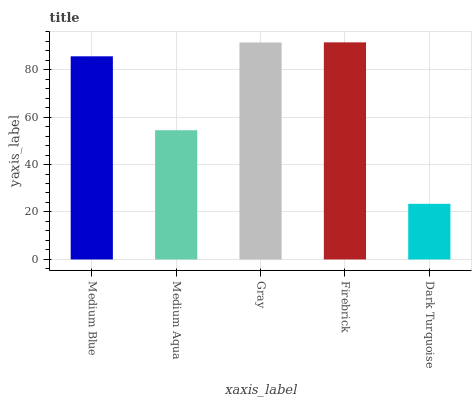Is Dark Turquoise the minimum?
Answer yes or no. Yes. Is Firebrick the maximum?
Answer yes or no. Yes. Is Medium Aqua the minimum?
Answer yes or no. No. Is Medium Aqua the maximum?
Answer yes or no. No. Is Medium Blue greater than Medium Aqua?
Answer yes or no. Yes. Is Medium Aqua less than Medium Blue?
Answer yes or no. Yes. Is Medium Aqua greater than Medium Blue?
Answer yes or no. No. Is Medium Blue less than Medium Aqua?
Answer yes or no. No. Is Medium Blue the high median?
Answer yes or no. Yes. Is Medium Blue the low median?
Answer yes or no. Yes. Is Firebrick the high median?
Answer yes or no. No. Is Gray the low median?
Answer yes or no. No. 